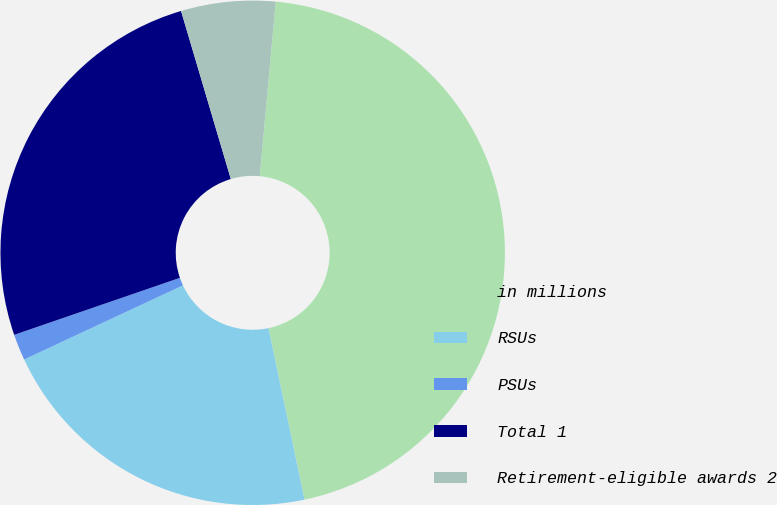Convert chart to OTSL. <chart><loc_0><loc_0><loc_500><loc_500><pie_chart><fcel>in millions<fcel>RSUs<fcel>PSUs<fcel>Total 1<fcel>Retirement-eligible awards 2<nl><fcel>45.25%<fcel>21.34%<fcel>1.68%<fcel>25.69%<fcel>6.04%<nl></chart> 